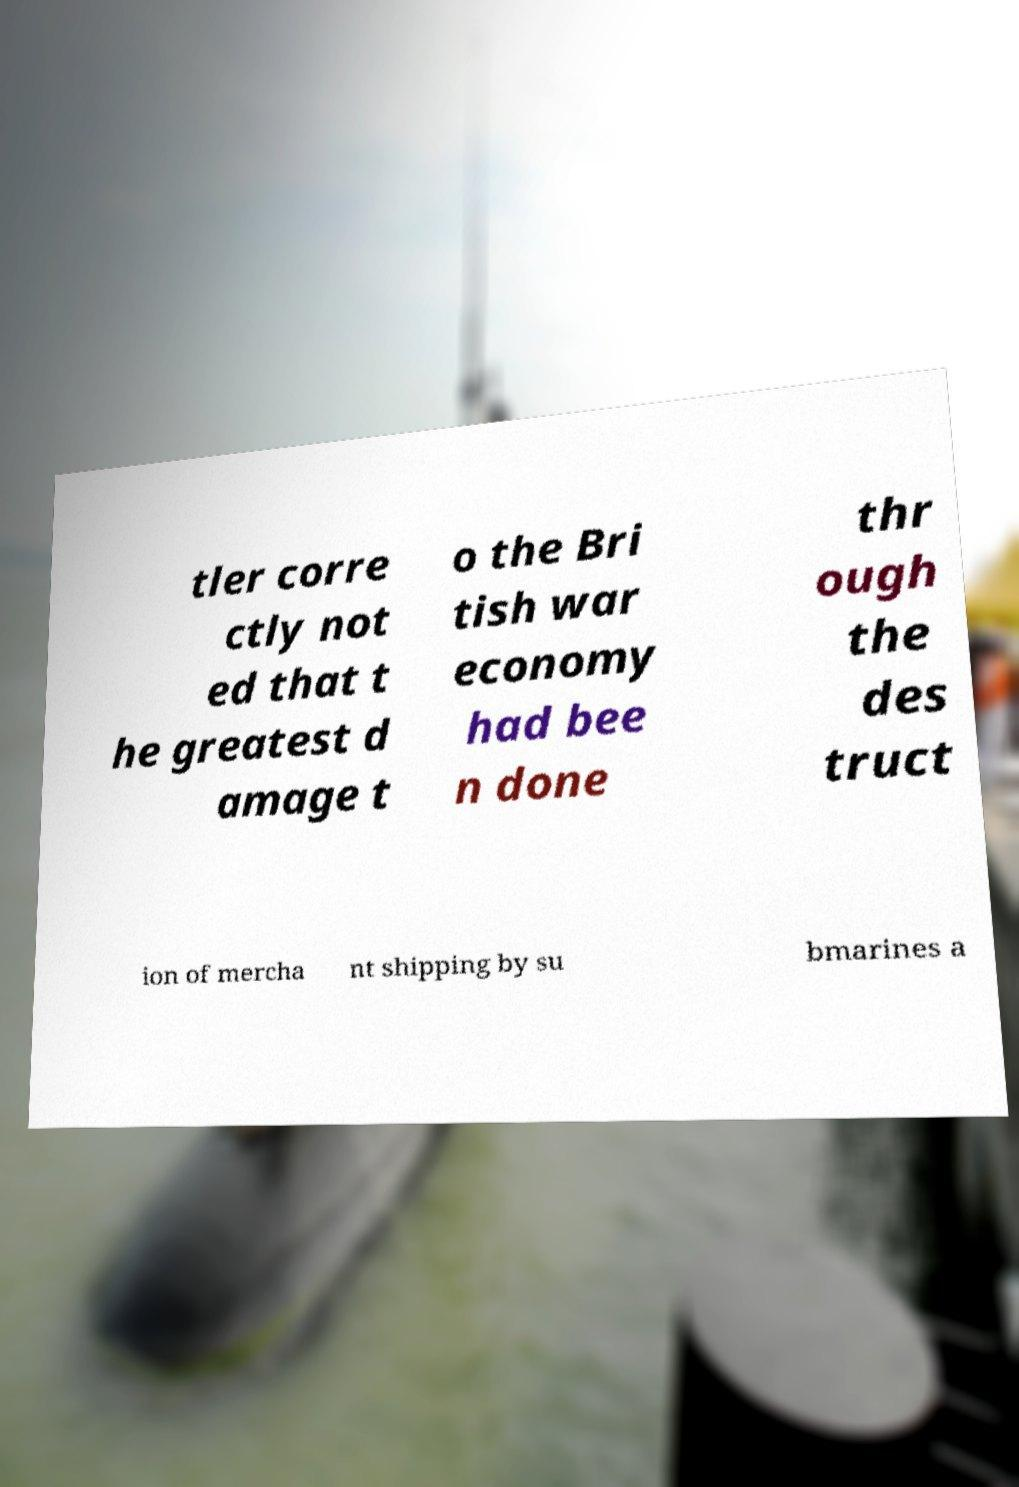I need the written content from this picture converted into text. Can you do that? tler corre ctly not ed that t he greatest d amage t o the Bri tish war economy had bee n done thr ough the des truct ion of mercha nt shipping by su bmarines a 